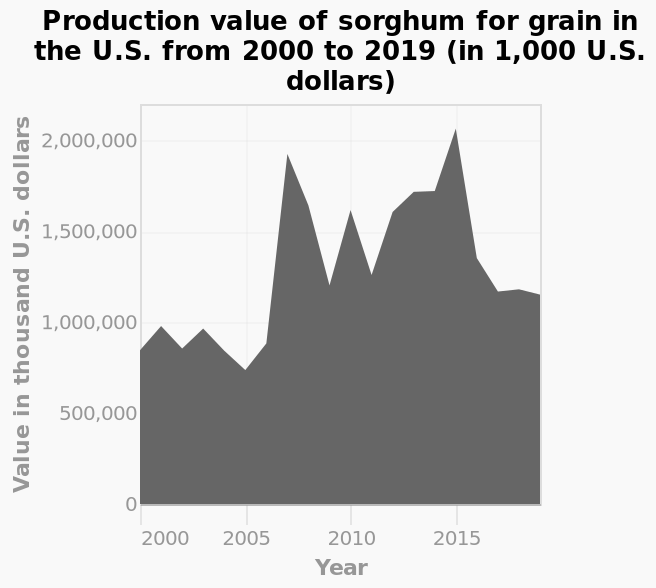<image>
What does the y-axis represent in the plot?  The y-axis represents the value of production in thousand U.S. dollars using a linear scale from 0 to 2,000,000. please describe the details of the chart Here a area plot is named Production value of sorghum for grain in the U.S. from 2000 to 2019 (in 1,000 U.S. dollars). The y-axis shows Value in thousand U.S. dollars using a linear scale from 0 to 2,000,000. There is a linear scale with a minimum of 2000 and a maximum of 2015 on the x-axis, marked Year. 